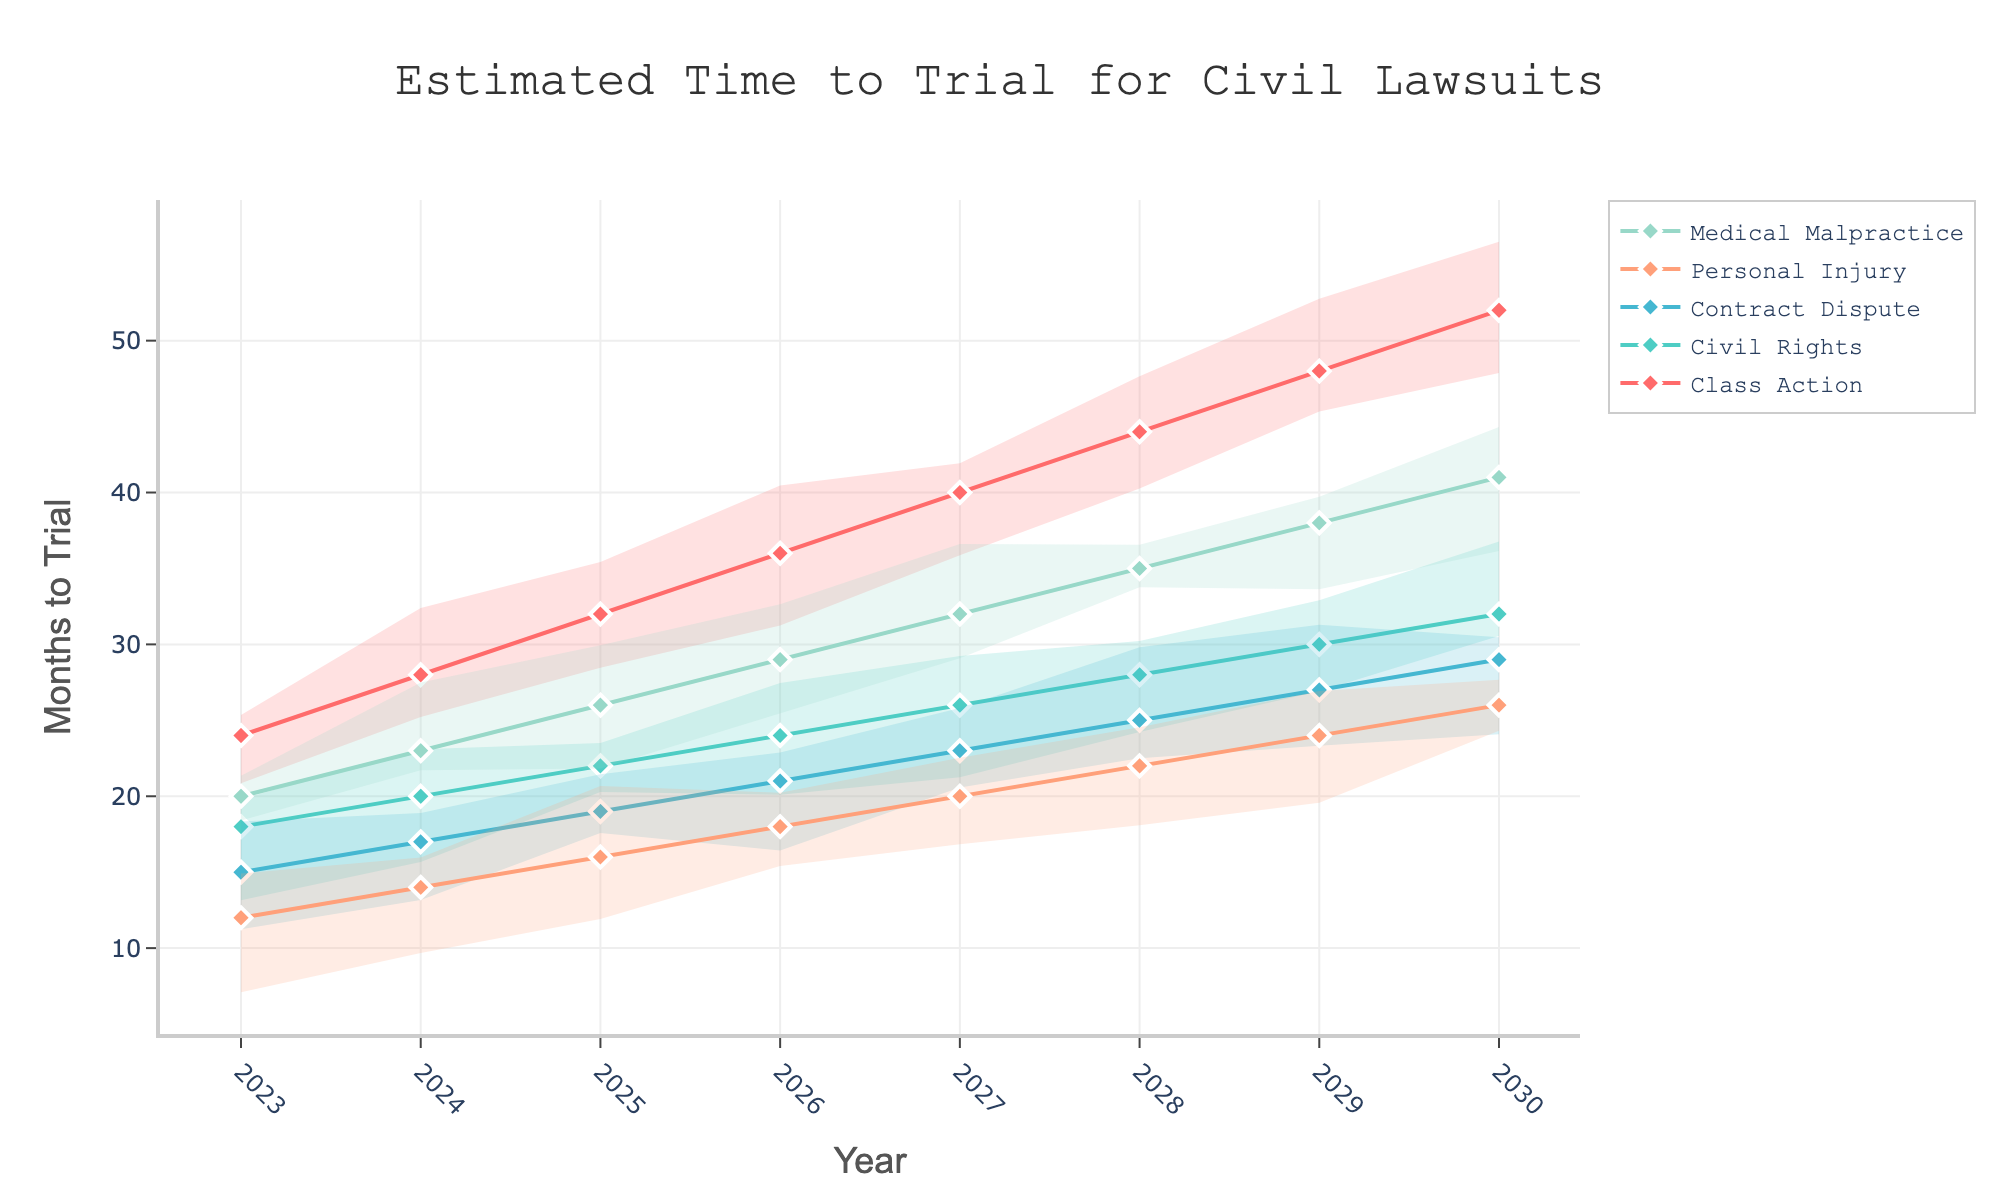What is the title of the plot? The title of the plot is usually displayed at the top center of the figure. In this case, it reads 'Estimated Time to Trial for Civil Lawsuits'.
Answer: 'Estimated Time to Trial for Civil Lawsuits' Which case type has the shortest estimated time to trial in 2023? Looking at the values for 2023 across all case types, 'Personal Injury' has an estimated time to trial of 12 months, which is the shortest.
Answer: 'Personal Injury' What is the estimated time to trial for Medical Malpractice cases in 2030? By locating the year 2030 on the x-axis and moving vertically to the Medical Malpractice line, we find the estimated time is 41 months.
Answer: 41 months Between which years does the estimated time to trial for Class Action cases pass 40 months? Locate the Class Action line and observe its values increasing. It surpasses 40 months between 2026 (36 months) and 2027 (40 months).
Answer: 2026 and 2027 How much does the estimated time to trial for Civil Rights cases increase from 2023 to 2025? From 2023 (18 months) to 2025 (22 months), the increase is 22 - 18 = 4 months.
Answer: 4 months Which case type shows the greatest increase in estimated time to trial between 2023 and 2030? By comparing each case type, Class Action increases from 24 to 52 months, which is an increase of 28 months, the largest among all case types.
Answer: 'Class Action' In what year does the contract dispute case's estimated time to trial equal the same as personal injury cases in 2028? Locate the values for Contract Dispute and Personal Injury in 2028. Both lines show an estimated time to trial of 22 months in 2028.
Answer: 2028 Compare the estimated time to trial for Personal Injury and Medical Malpractice cases in 2025. Which has the greater value? In 2025, Personal Injury is 16 months and Medical Malpractice is 26 months. Medical Malpractice has the greater value.
Answer: 'Medical Malpractice' For the year 2029, which case types have an estimated time to trial within the uncertainty band of Civil Rights cases? The uncertainty band for Civil Rights in 2029 ranges from its upper to lower band (30 ± 1-5). Contract Dispute (27), Personal Injury (24) and Medical Malpractice (38) fall within this range.
Answer: 'Contract Dispute, Personal Injury' 